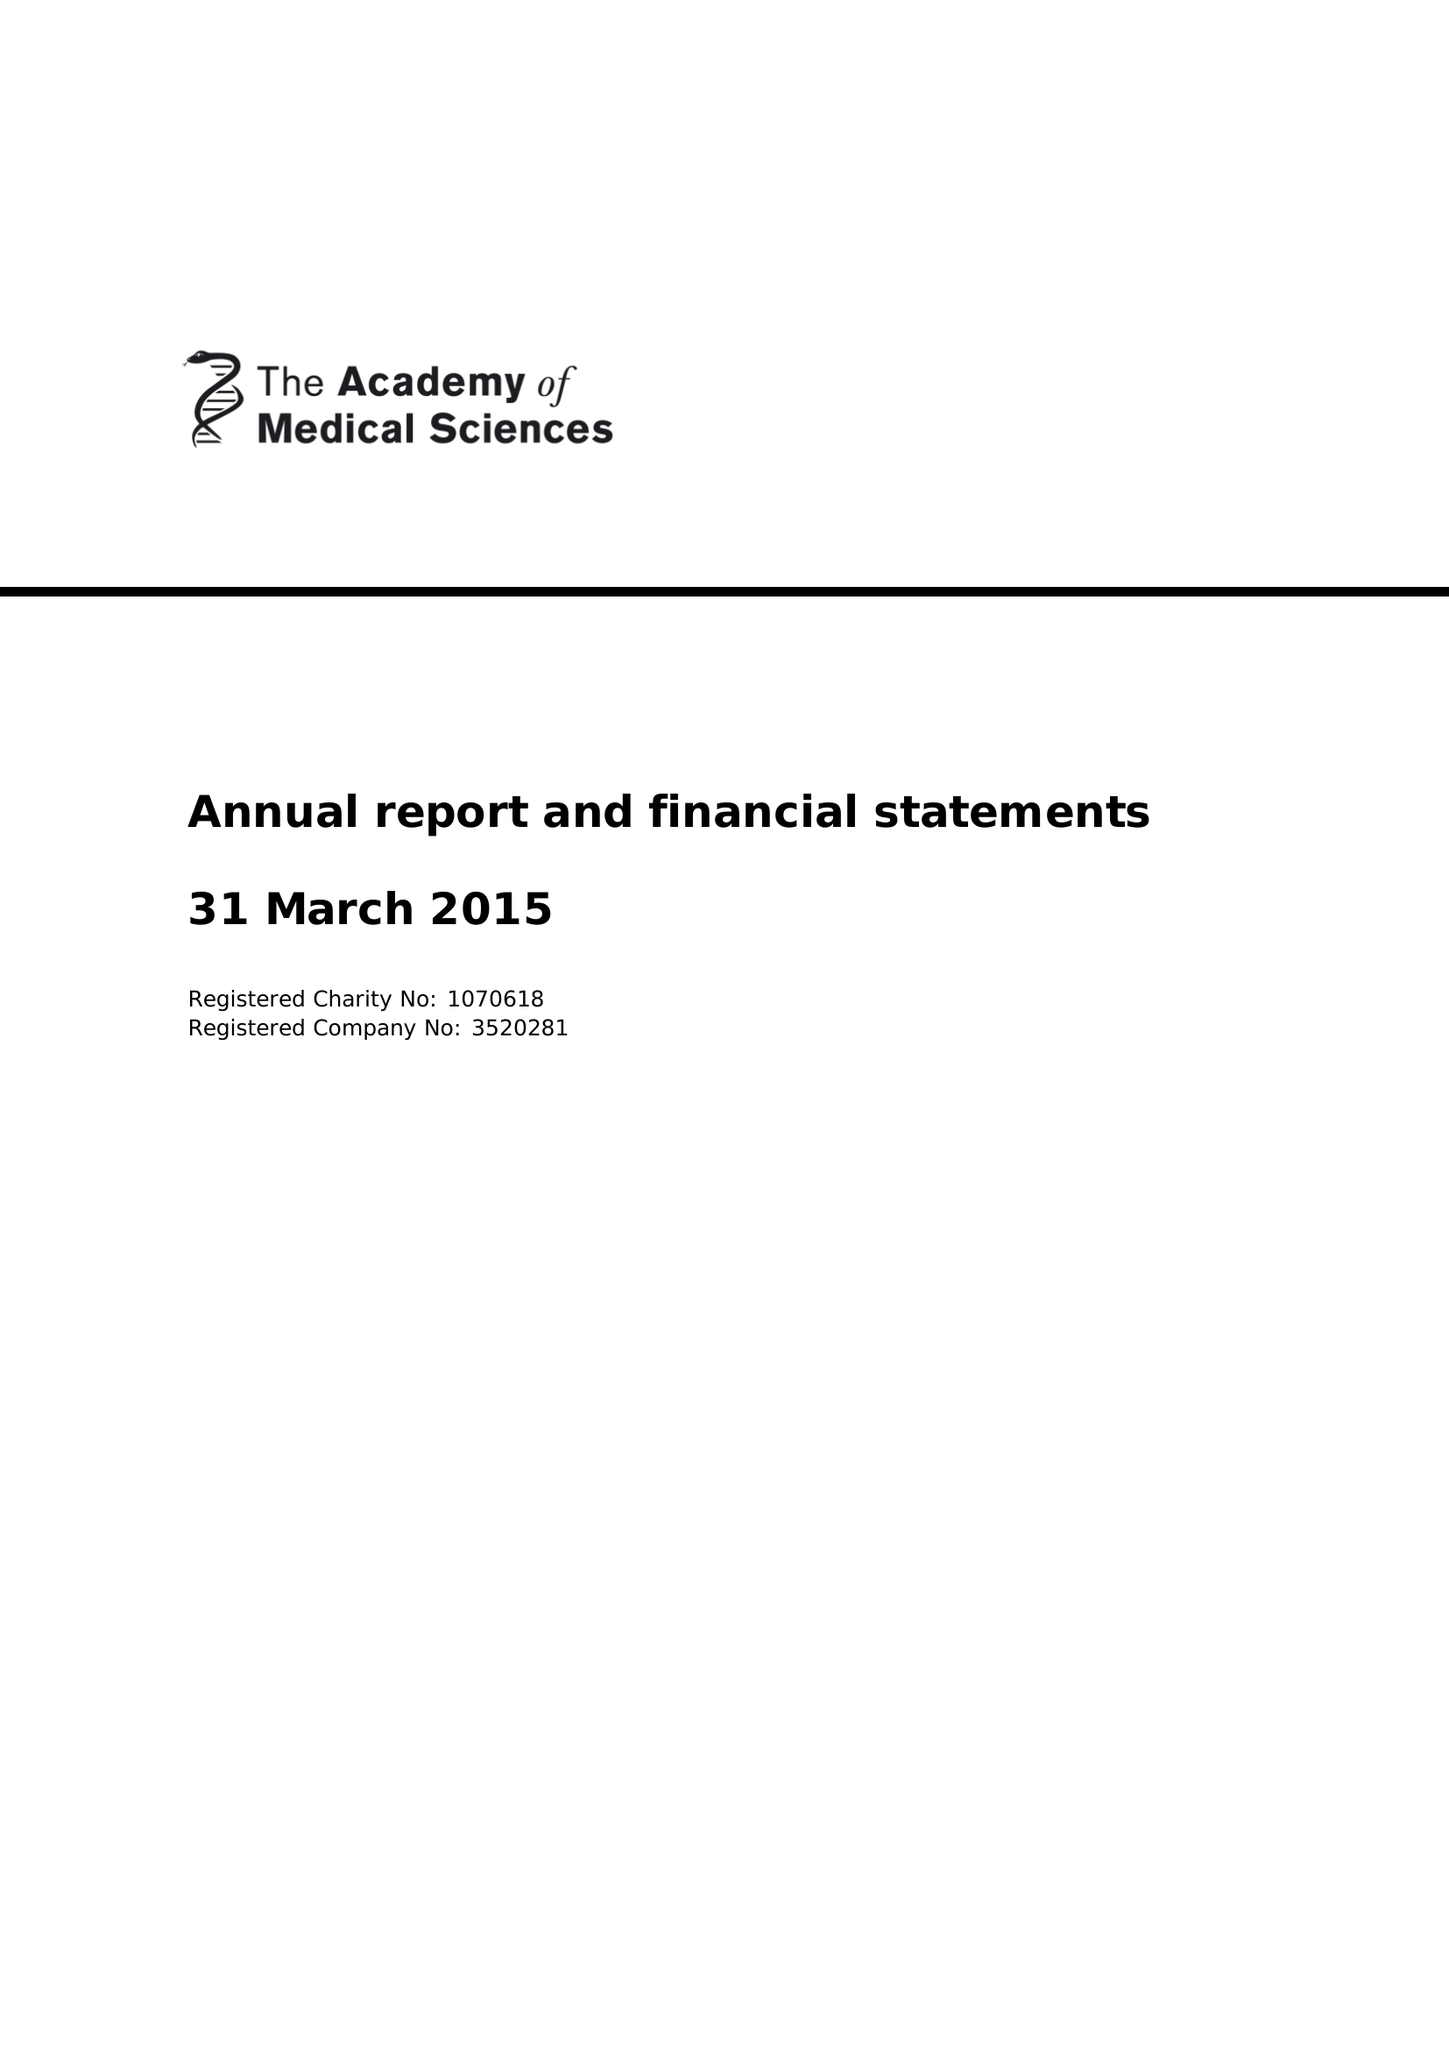What is the value for the spending_annually_in_british_pounds?
Answer the question using a single word or phrase. 5560909.00 